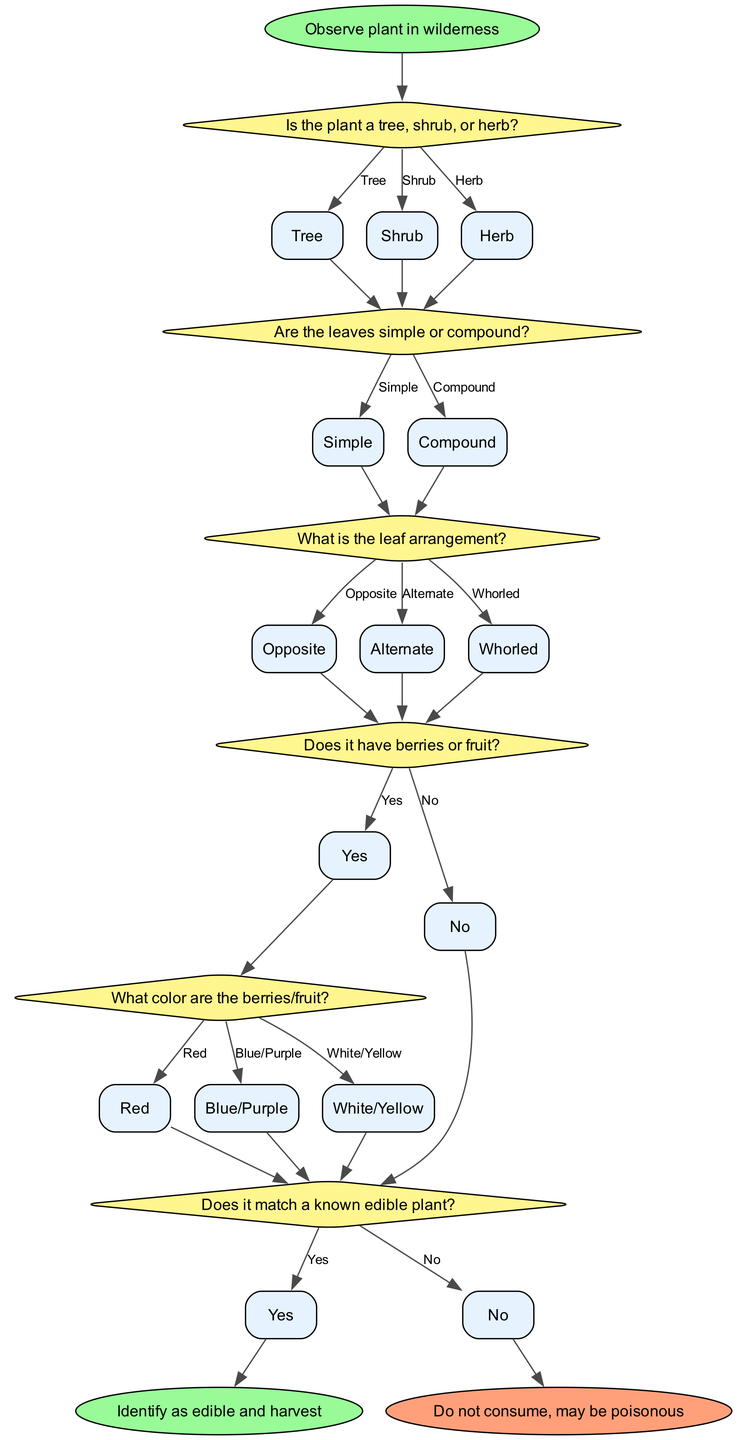What is the first step in the decision tree? The first step is to "Observe plant in wilderness." This initiates the process of identifying whether the plant is edible.
Answer: Observe plant in wilderness How many decision nodes are there in the diagram? The diagram contains six decision nodes that guide the identification process based on various characteristics of the plant.
Answer: Six What options are available if the plant is a shrub? If the plant is identified as a shrub, it leads directly to the second decision node about leaf types. Thus, the next decision concerns whether the leaves are simple or compound.
Answer: Decision about leaves What happens if the option selected for leaf arrangement is alternate? Selecting "Alternate" leads to the decision about whether the plant has berries or fruit, moving down the pathway of the decision tree.
Answer: Next decision about berries If the plant's berries are blue/purple, what will be the next decision? After identifying that the berries are blue/purple, the next decision will ask whether it matches a known edible plant. This occurs before identifying if the plant is edible.
Answer: Decision about matching edible plants What is the outcome if it does match a known edible plant? If the plant matches a known edible plant, the outcome recorded at the end of the flowchart will be to "Identify as edible and harvest." This indicates that the plant is safe for consumption.
Answer: Identify as edible and harvest What will happen if the plant has no berries or fruit? If the plant is determined to have no berries or fruit, it will lead to a decision about whether it matches a known edible plant, which is crucial for concluding its safety for consumption.
Answer: Decision about matching edible plants Which node leads to a warning about potential poison? The final decision path that leads to the outcome "Do not consume, may be poisonous" is initiated from the decision confirming it does not match known edible plants.
Answer: Do not consume, may be poisonous 